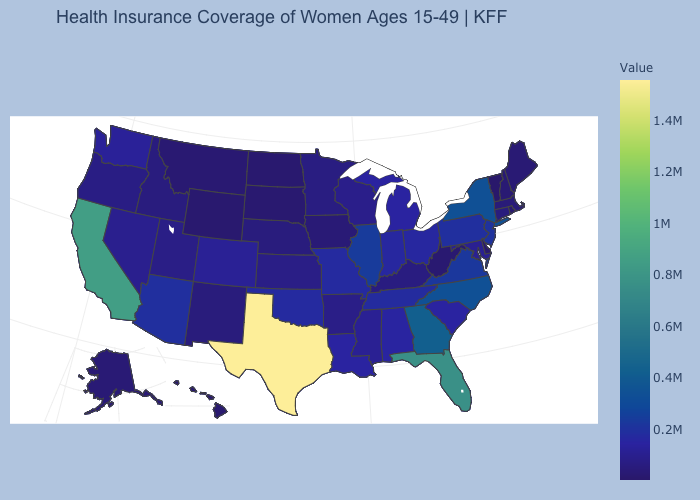Which states have the lowest value in the West?
Concise answer only. Hawaii. Which states hav the highest value in the West?
Short answer required. California. Which states have the highest value in the USA?
Answer briefly. Texas. Which states have the lowest value in the USA?
Quick response, please. Vermont. Among the states that border Maine , which have the lowest value?
Answer briefly. New Hampshire. 